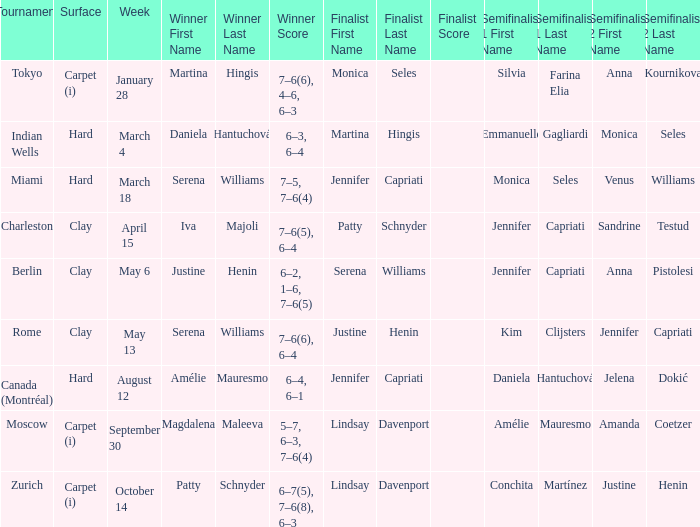What tournament had finalist Monica Seles? Tokyo. 